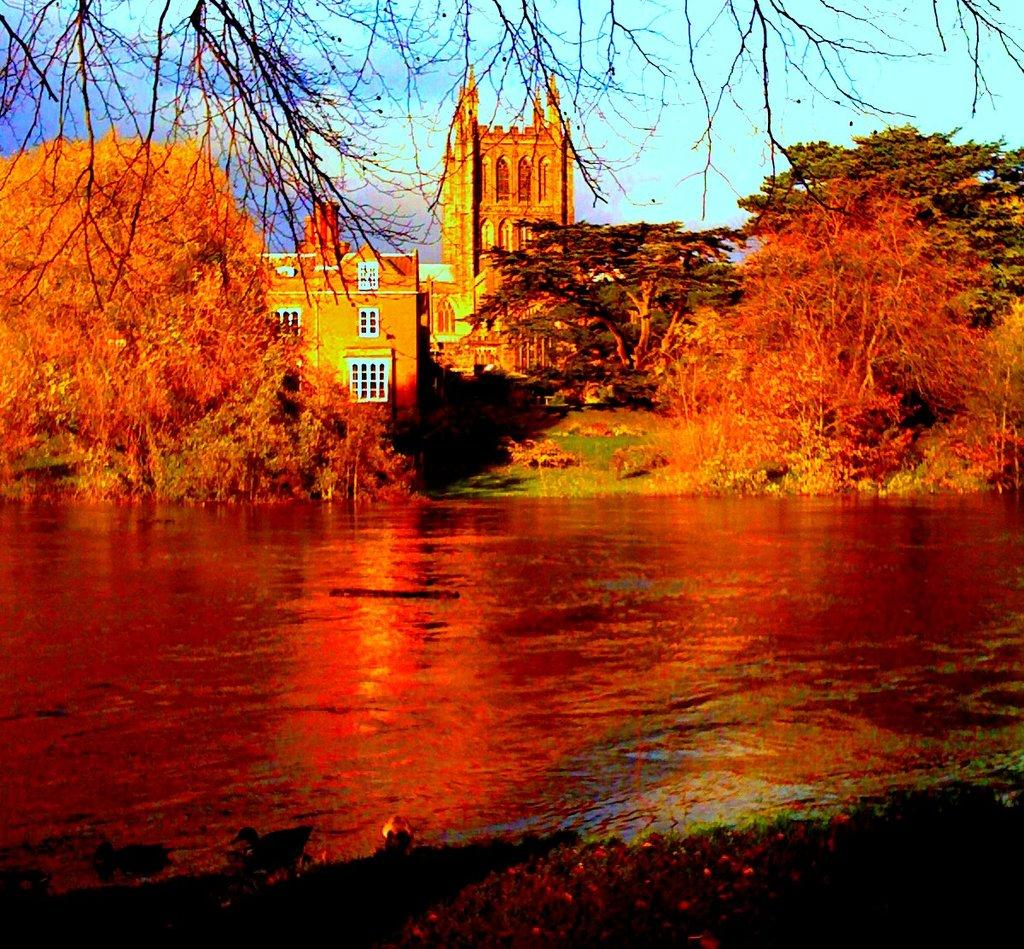What type of natural elements can be seen in the image? There are trees in the image. What type of man-made structures are present in the image? There are buildings in the image. What body of water is visible in the image? There is water visible in the image. What is visible in the background of the image? The sky is visible in the background of the image. How many buttons are visible on the trees in the image? There are no buttons present on the trees in the image. What type of ice can be seen melting in the water in the image? There is no ice present in the water in the image. 